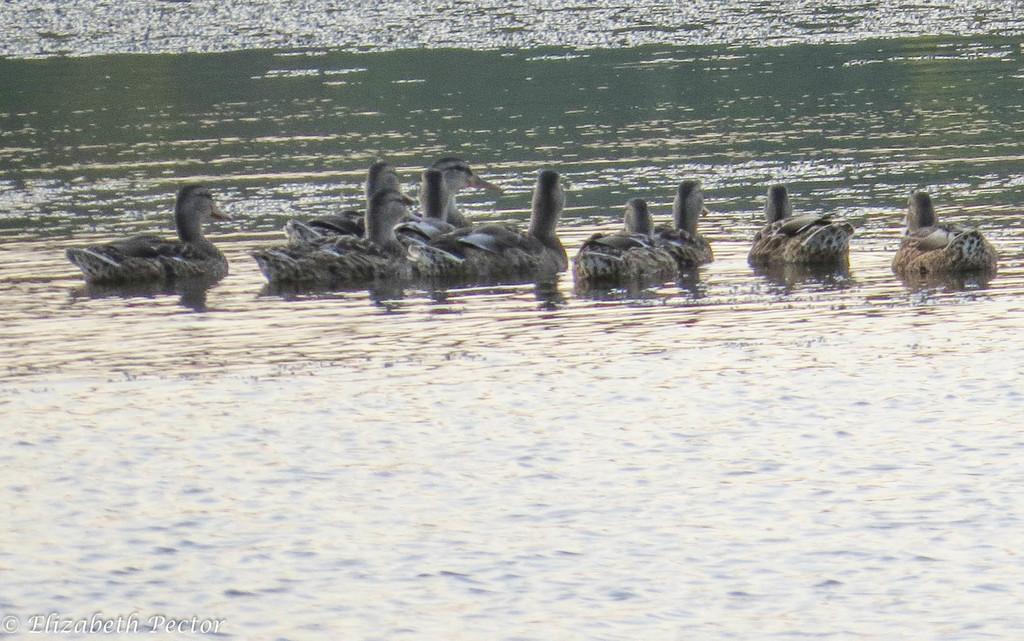Please provide a concise description of this image. In the picture we can see water on it we can see some ducks which are black and some gray in color. 